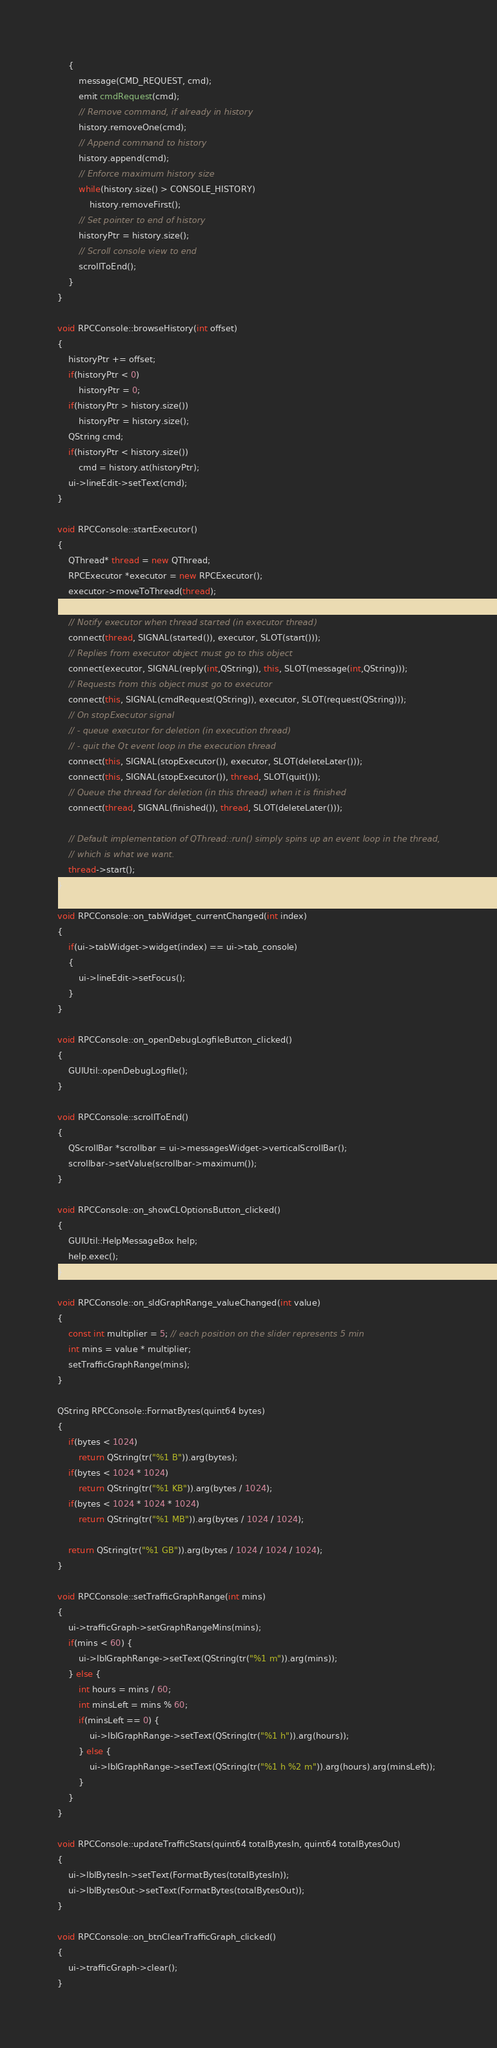<code> <loc_0><loc_0><loc_500><loc_500><_C++_>    {
        message(CMD_REQUEST, cmd);
        emit cmdRequest(cmd);
        // Remove command, if already in history
        history.removeOne(cmd);
        // Append command to history
        history.append(cmd);
        // Enforce maximum history size
        while(history.size() > CONSOLE_HISTORY)
            history.removeFirst();
        // Set pointer to end of history
        historyPtr = history.size();
        // Scroll console view to end
        scrollToEnd();
    }
}

void RPCConsole::browseHistory(int offset)
{
    historyPtr += offset;
    if(historyPtr < 0)
        historyPtr = 0;
    if(historyPtr > history.size())
        historyPtr = history.size();
    QString cmd;
    if(historyPtr < history.size())
        cmd = history.at(historyPtr);
    ui->lineEdit->setText(cmd);
}

void RPCConsole::startExecutor()
{
    QThread* thread = new QThread;
    RPCExecutor *executor = new RPCExecutor();
    executor->moveToThread(thread);

    // Notify executor when thread started (in executor thread)
    connect(thread, SIGNAL(started()), executor, SLOT(start()));
    // Replies from executor object must go to this object
    connect(executor, SIGNAL(reply(int,QString)), this, SLOT(message(int,QString)));
    // Requests from this object must go to executor
    connect(this, SIGNAL(cmdRequest(QString)), executor, SLOT(request(QString)));
    // On stopExecutor signal
    // - queue executor for deletion (in execution thread)
    // - quit the Qt event loop in the execution thread
    connect(this, SIGNAL(stopExecutor()), executor, SLOT(deleteLater()));
    connect(this, SIGNAL(stopExecutor()), thread, SLOT(quit()));
    // Queue the thread for deletion (in this thread) when it is finished
    connect(thread, SIGNAL(finished()), thread, SLOT(deleteLater()));

    // Default implementation of QThread::run() simply spins up an event loop in the thread,
    // which is what we want.
    thread->start();
}

void RPCConsole::on_tabWidget_currentChanged(int index)
{
    if(ui->tabWidget->widget(index) == ui->tab_console)
    {
        ui->lineEdit->setFocus();
    }
}

void RPCConsole::on_openDebugLogfileButton_clicked()
{
    GUIUtil::openDebugLogfile();
}

void RPCConsole::scrollToEnd()
{
    QScrollBar *scrollbar = ui->messagesWidget->verticalScrollBar();
    scrollbar->setValue(scrollbar->maximum());
}

void RPCConsole::on_showCLOptionsButton_clicked()
{
    GUIUtil::HelpMessageBox help;
    help.exec();
}

void RPCConsole::on_sldGraphRange_valueChanged(int value)
{
    const int multiplier = 5; // each position on the slider represents 5 min
    int mins = value * multiplier;
    setTrafficGraphRange(mins);
}

QString RPCConsole::FormatBytes(quint64 bytes)
{
    if(bytes < 1024)
        return QString(tr("%1 B")).arg(bytes);
    if(bytes < 1024 * 1024)
        return QString(tr("%1 KB")).arg(bytes / 1024);
    if(bytes < 1024 * 1024 * 1024)
        return QString(tr("%1 MB")).arg(bytes / 1024 / 1024);

    return QString(tr("%1 GB")).arg(bytes / 1024 / 1024 / 1024);
}

void RPCConsole::setTrafficGraphRange(int mins)
{
    ui->trafficGraph->setGraphRangeMins(mins);
    if(mins < 60) {
        ui->lblGraphRange->setText(QString(tr("%1 m")).arg(mins));
    } else {
        int hours = mins / 60;
        int minsLeft = mins % 60;
        if(minsLeft == 0) {
            ui->lblGraphRange->setText(QString(tr("%1 h")).arg(hours));
        } else {
            ui->lblGraphRange->setText(QString(tr("%1 h %2 m")).arg(hours).arg(minsLeft));
        }
    }
}

void RPCConsole::updateTrafficStats(quint64 totalBytesIn, quint64 totalBytesOut)
{
    ui->lblBytesIn->setText(FormatBytes(totalBytesIn));
    ui->lblBytesOut->setText(FormatBytes(totalBytesOut));
}

void RPCConsole::on_btnClearTrafficGraph_clicked()
{
    ui->trafficGraph->clear();
}
</code> 